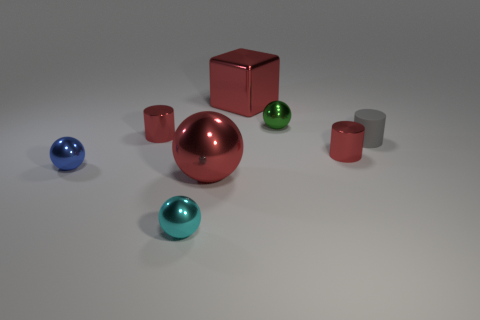Subtract 1 balls. How many balls are left? 3 Add 1 rubber cylinders. How many objects exist? 9 Subtract all cylinders. How many objects are left? 5 Subtract all green things. Subtract all big objects. How many objects are left? 5 Add 5 balls. How many balls are left? 9 Add 7 cyan shiny things. How many cyan shiny things exist? 8 Subtract 0 yellow spheres. How many objects are left? 8 